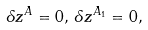Convert formula to latex. <formula><loc_0><loc_0><loc_500><loc_500>\delta z ^ { A } = 0 , \, \delta z ^ { A _ { 1 } } = 0 ,</formula> 